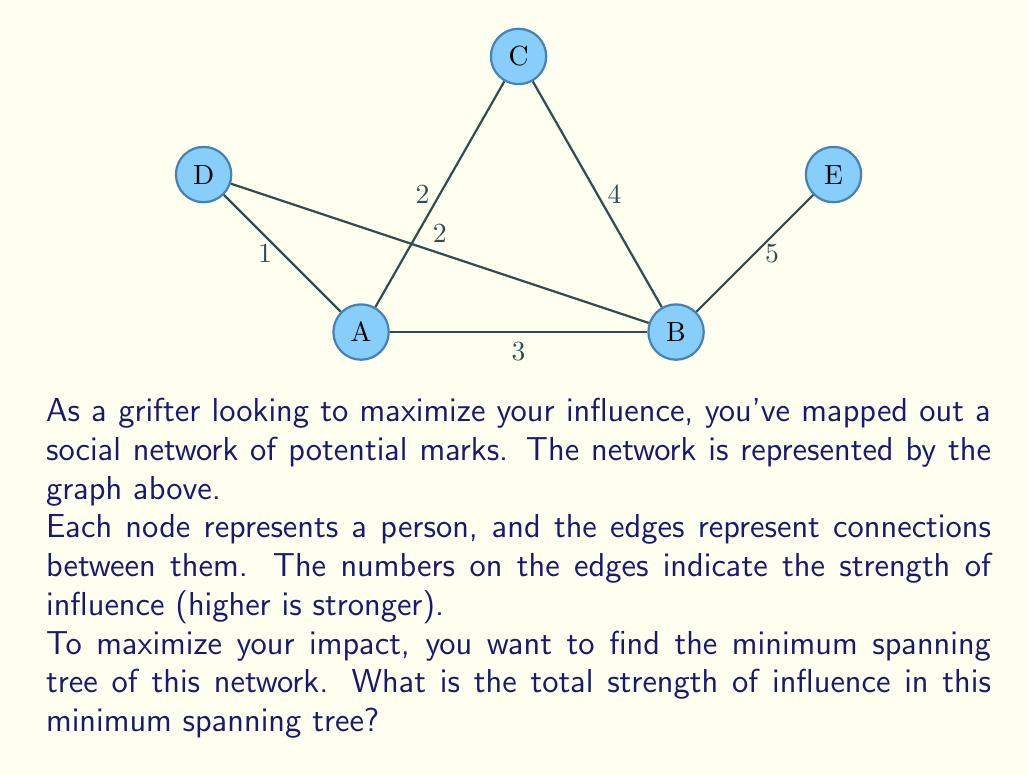Teach me how to tackle this problem. To solve this problem, we'll use Kruskal's algorithm to find the minimum spanning tree (MST) of the given graph. This will give us the network configuration with the minimum total influence strength, which is ideal for a grifter looking to efficiently spread their influence.

Steps:

1) First, sort all edges by weight (influence strength) in ascending order:
   (A,D): 1
   (A,C): 2
   (B,D): 2
   (A,B): 3
   (B,C): 4
   (B,E): 5

2) Start with an empty MST and add edges one by one, ensuring no cycles are formed:

   - Add (A,D): 1
   MST: A-D (total weight: 1)

   - Add (A,C): 2
   MST: A-D, A-C (total weight: 3)

   - Add (B,D): 2
   MST: A-D, A-C, B-D (total weight: 5)

   - Try to add (A,B): 3, but this would form a cycle, so skip it.

   - Add (B,E): 5
   MST: A-D, A-C, B-D, B-E (total weight: 10)

3) We've now included all nodes in our MST, so we're done.

The minimum spanning tree consists of the edges: (A,D), (A,C), (B,D), and (B,E).

The total strength of influence in this MST is the sum of the weights of these edges:
$$ 1 + 2 + 2 + 5 = 10 $$
Answer: 10 